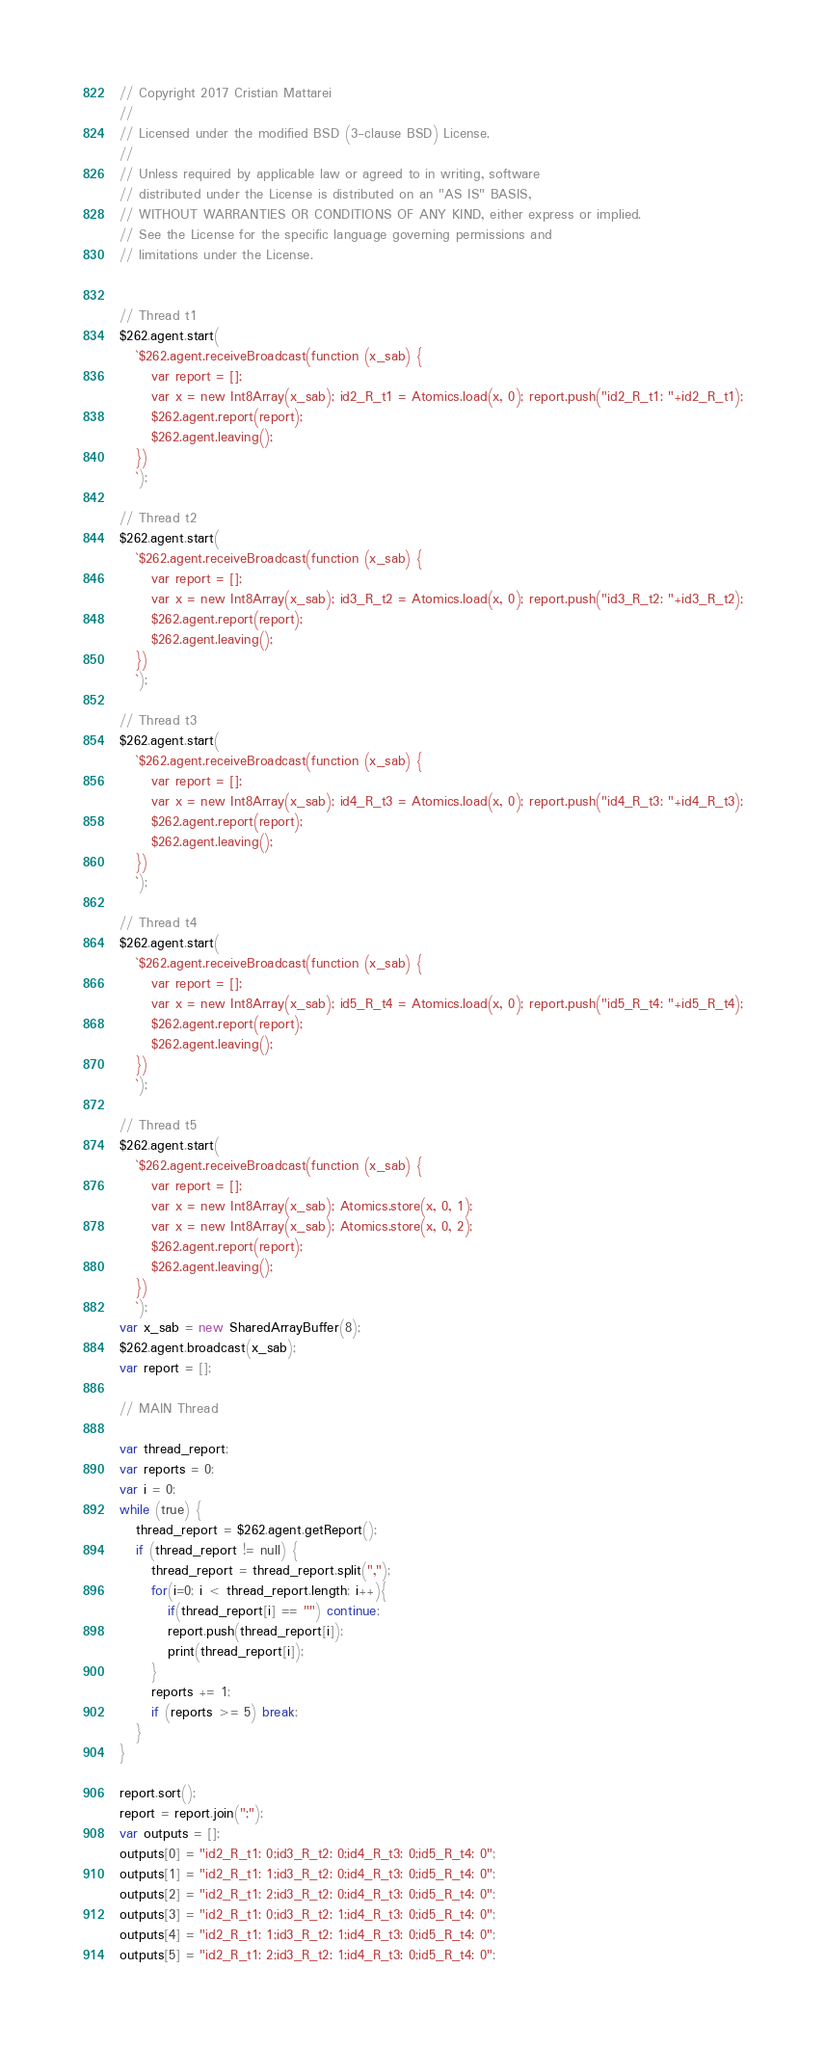<code> <loc_0><loc_0><loc_500><loc_500><_JavaScript_>// Copyright 2017 Cristian Mattarei
//
// Licensed under the modified BSD (3-clause BSD) License.
//
// Unless required by applicable law or agreed to in writing, software
// distributed under the License is distributed on an "AS IS" BASIS,
// WITHOUT WARRANTIES OR CONDITIONS OF ANY KIND, either express or implied.
// See the License for the specific language governing permissions and
// limitations under the License.


// Thread t1
$262.agent.start(
   `$262.agent.receiveBroadcast(function (x_sab) {
      var report = [];
      var x = new Int8Array(x_sab); id2_R_t1 = Atomics.load(x, 0); report.push("id2_R_t1: "+id2_R_t1);
      $262.agent.report(report);
      $262.agent.leaving();
   })
   `);

// Thread t2
$262.agent.start(
   `$262.agent.receiveBroadcast(function (x_sab) {
      var report = [];
      var x = new Int8Array(x_sab); id3_R_t2 = Atomics.load(x, 0); report.push("id3_R_t2: "+id3_R_t2);
      $262.agent.report(report);
      $262.agent.leaving();
   })
   `);

// Thread t3
$262.agent.start(
   `$262.agent.receiveBroadcast(function (x_sab) {
      var report = [];
      var x = new Int8Array(x_sab); id4_R_t3 = Atomics.load(x, 0); report.push("id4_R_t3: "+id4_R_t3);
      $262.agent.report(report);
      $262.agent.leaving();
   })
   `);

// Thread t4
$262.agent.start(
   `$262.agent.receiveBroadcast(function (x_sab) {
      var report = [];
      var x = new Int8Array(x_sab); id5_R_t4 = Atomics.load(x, 0); report.push("id5_R_t4: "+id5_R_t4);
      $262.agent.report(report);
      $262.agent.leaving();
   })
   `);

// Thread t5
$262.agent.start(
   `$262.agent.receiveBroadcast(function (x_sab) {
      var report = [];
      var x = new Int8Array(x_sab); Atomics.store(x, 0, 1);
      var x = new Int8Array(x_sab); Atomics.store(x, 0, 2);
      $262.agent.report(report);
      $262.agent.leaving();
   })
   `);
var x_sab = new SharedArrayBuffer(8);
$262.agent.broadcast(x_sab);
var report = [];

// MAIN Thread

var thread_report;
var reports = 0;
var i = 0;
while (true) {
   thread_report = $262.agent.getReport();
   if (thread_report != null) {
      thread_report = thread_report.split(",");
      for(i=0; i < thread_report.length; i++){
         if(thread_report[i] == "") continue;
         report.push(thread_report[i]);
         print(thread_report[i]);
      }
      reports += 1;
      if (reports >= 5) break;
   }
}

report.sort();
report = report.join(";");
var outputs = [];
outputs[0] = "id2_R_t1: 0;id3_R_t2: 0;id4_R_t3: 0;id5_R_t4: 0";
outputs[1] = "id2_R_t1: 1;id3_R_t2: 0;id4_R_t3: 0;id5_R_t4: 0";
outputs[2] = "id2_R_t1: 2;id3_R_t2: 0;id4_R_t3: 0;id5_R_t4: 0";
outputs[3] = "id2_R_t1: 0;id3_R_t2: 1;id4_R_t3: 0;id5_R_t4: 0";
outputs[4] = "id2_R_t1: 1;id3_R_t2: 1;id4_R_t3: 0;id5_R_t4: 0";
outputs[5] = "id2_R_t1: 2;id3_R_t2: 1;id4_R_t3: 0;id5_R_t4: 0";</code> 